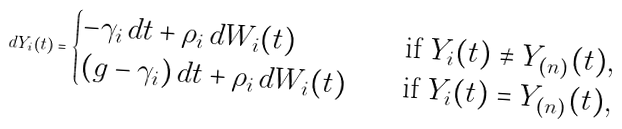Convert formula to latex. <formula><loc_0><loc_0><loc_500><loc_500>d Y _ { i } ( t ) = \begin{cases} - \gamma _ { i } \, d t + \rho _ { i } \, d W _ { i } ( t ) \quad & \text {if $Y_{i}(t) \ne Y_{(n)}(t)$} , \\ ( g - \gamma _ { i } ) \, d t + \rho _ { i } \, d W _ { i } ( t ) \quad & \text {if $Y_{i}(t) = Y_{(n)}(t)$} , \end{cases}</formula> 